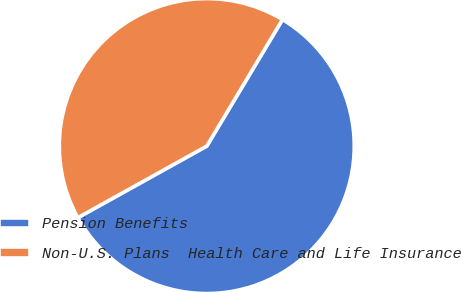Convert chart to OTSL. <chart><loc_0><loc_0><loc_500><loc_500><pie_chart><fcel>Pension Benefits<fcel>Non-U.S. Plans  Health Care and Life Insurance<nl><fcel>58.35%<fcel>41.65%<nl></chart> 